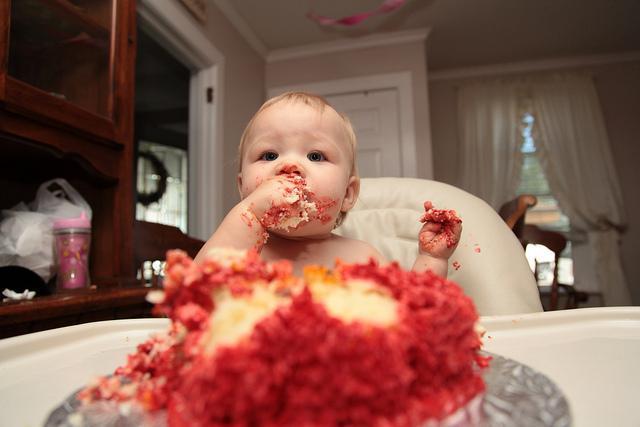How many chairs are in the picture?
Give a very brief answer. 3. 